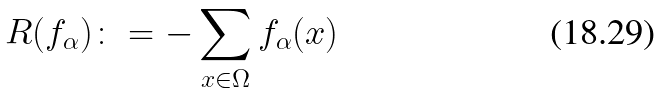Convert formula to latex. <formula><loc_0><loc_0><loc_500><loc_500>R ( f _ { \alpha } ) \colon = - \sum _ { { x } \in \Omega } f _ { \alpha } ( { x } )</formula> 